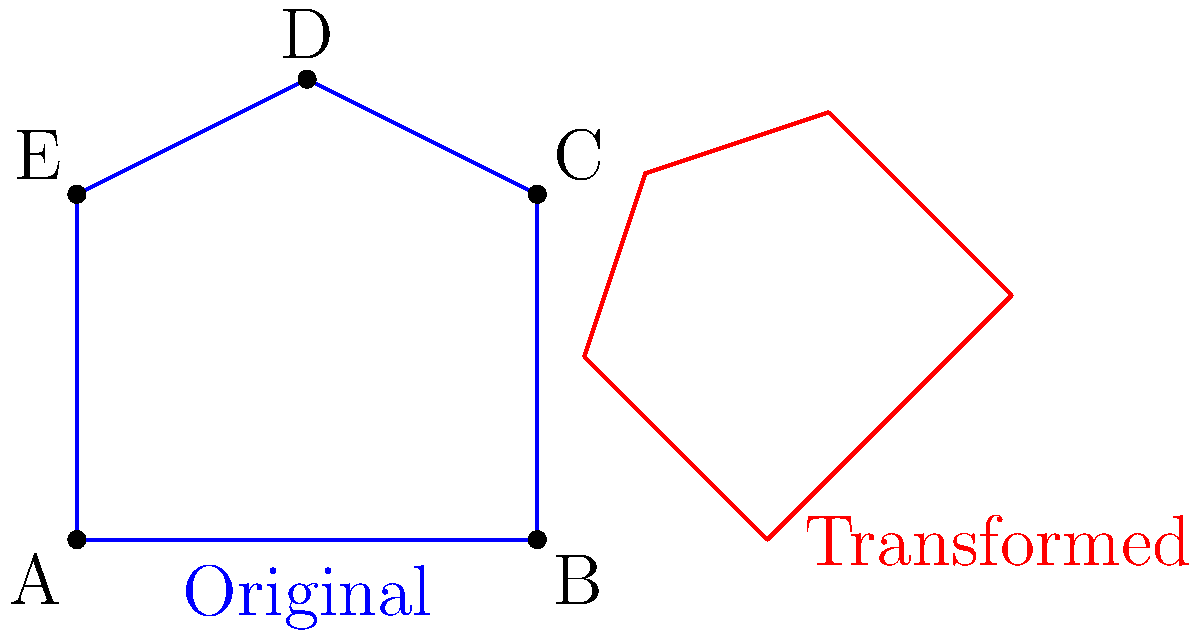Consider the simplified outline of the National Parliament House of Bangladesh shown in blue. If this shape undergoes a series of transformations in the following order: scaling by a factor of 0.75, rotation by 45° clockwise, and translation 6 units to the right, what will be the coordinates of point D in the final transformed shape (shown in red)? Let's approach this step-by-step:

1) The original coordinates of point D are (2,4).

2) Scaling by 0.75:
   $x' = 0.75 * 2 = 1.5$
   $y' = 0.75 * 4 = 3$
   After scaling: (1.5, 3)

3) Rotation by 45° clockwise:
   We use the rotation matrix:
   $\begin{bmatrix} \cos 45° & \sin 45° \\ -\sin 45° & \cos 45° \end{bmatrix}$
   $\begin{bmatrix} \frac{\sqrt{2}}{2} & \frac{\sqrt{2}}{2} \\ -\frac{\sqrt{2}}{2} & \frac{\sqrt{2}}{2} \end{bmatrix}$

   $x'' = 1.5 * \frac{\sqrt{2}}{2} + 3 * \frac{\sqrt{2}}{2} = \frac{4.5\sqrt{2}}{2}$
   $y'' = -1.5 * \frac{\sqrt{2}}{2} + 3 * \frac{\sqrt{2}}{2} = \frac{1.5\sqrt{2}}{2}$

4) Translation 6 units to the right:
   $x''' = \frac{4.5\sqrt{2}}{2} + 6$
   $y''' = \frac{1.5\sqrt{2}}{2}$

Therefore, the final coordinates of point D are $(\frac{4.5\sqrt{2}}{2} + 6, \frac{1.5\sqrt{2}}{2})$.
Answer: $(\frac{4.5\sqrt{2}}{2} + 6, \frac{1.5\sqrt{2}}{2})$ 